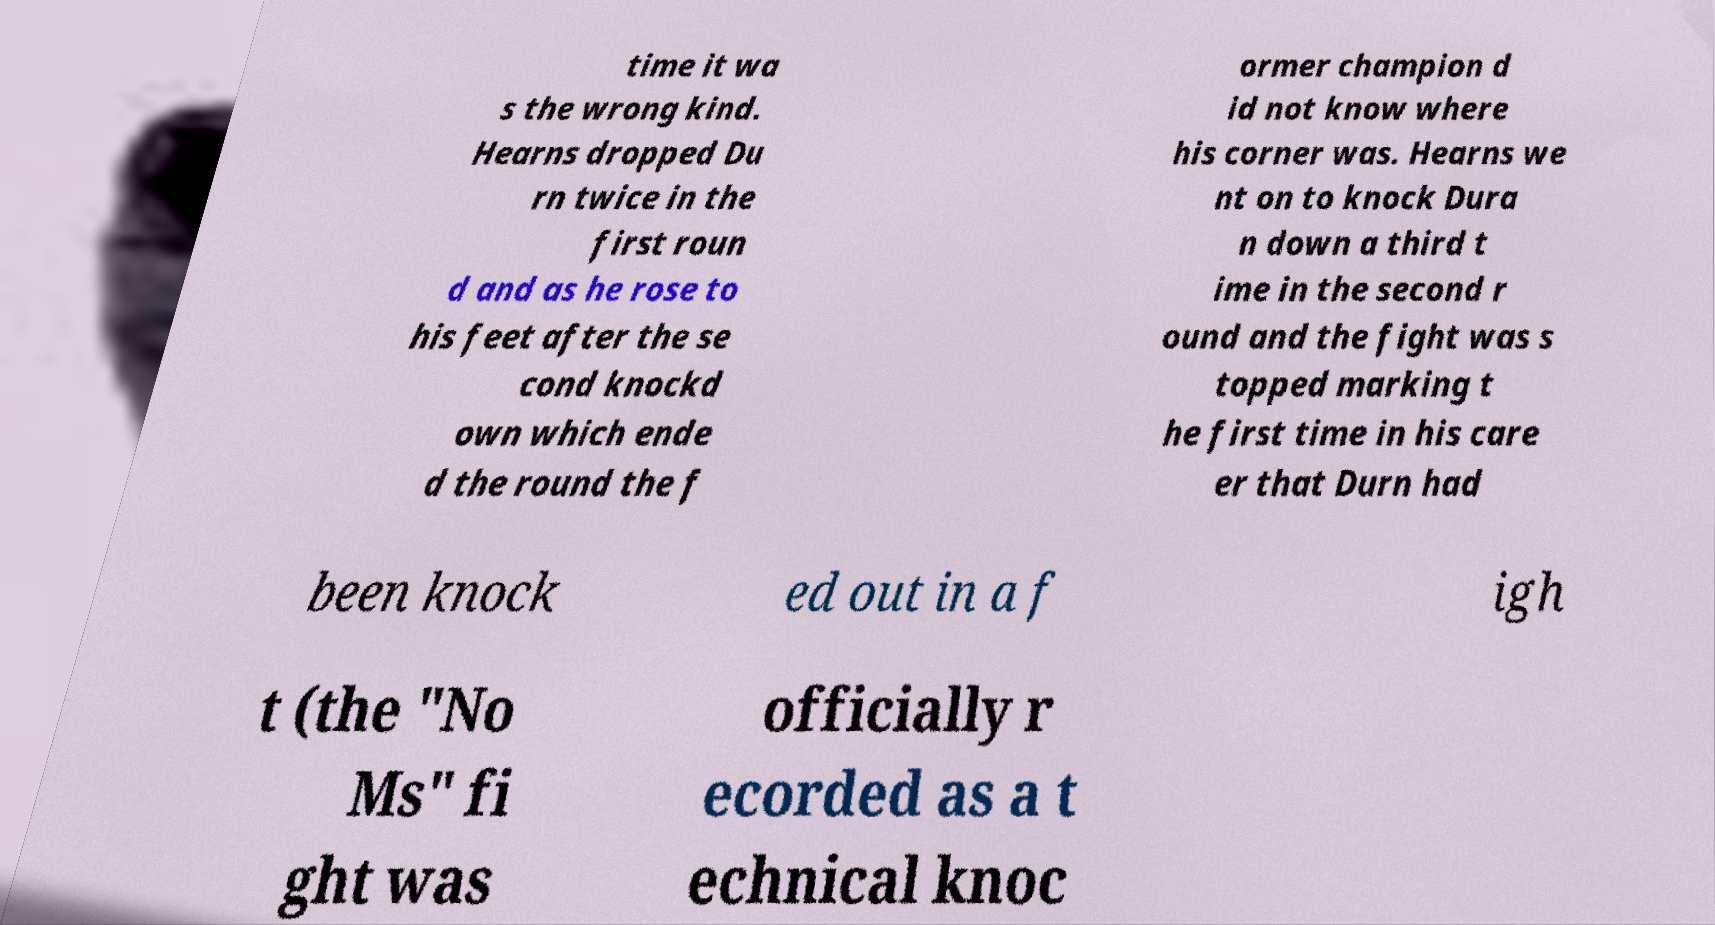Can you accurately transcribe the text from the provided image for me? time it wa s the wrong kind. Hearns dropped Du rn twice in the first roun d and as he rose to his feet after the se cond knockd own which ende d the round the f ormer champion d id not know where his corner was. Hearns we nt on to knock Dura n down a third t ime in the second r ound and the fight was s topped marking t he first time in his care er that Durn had been knock ed out in a f igh t (the "No Ms" fi ght was officially r ecorded as a t echnical knoc 